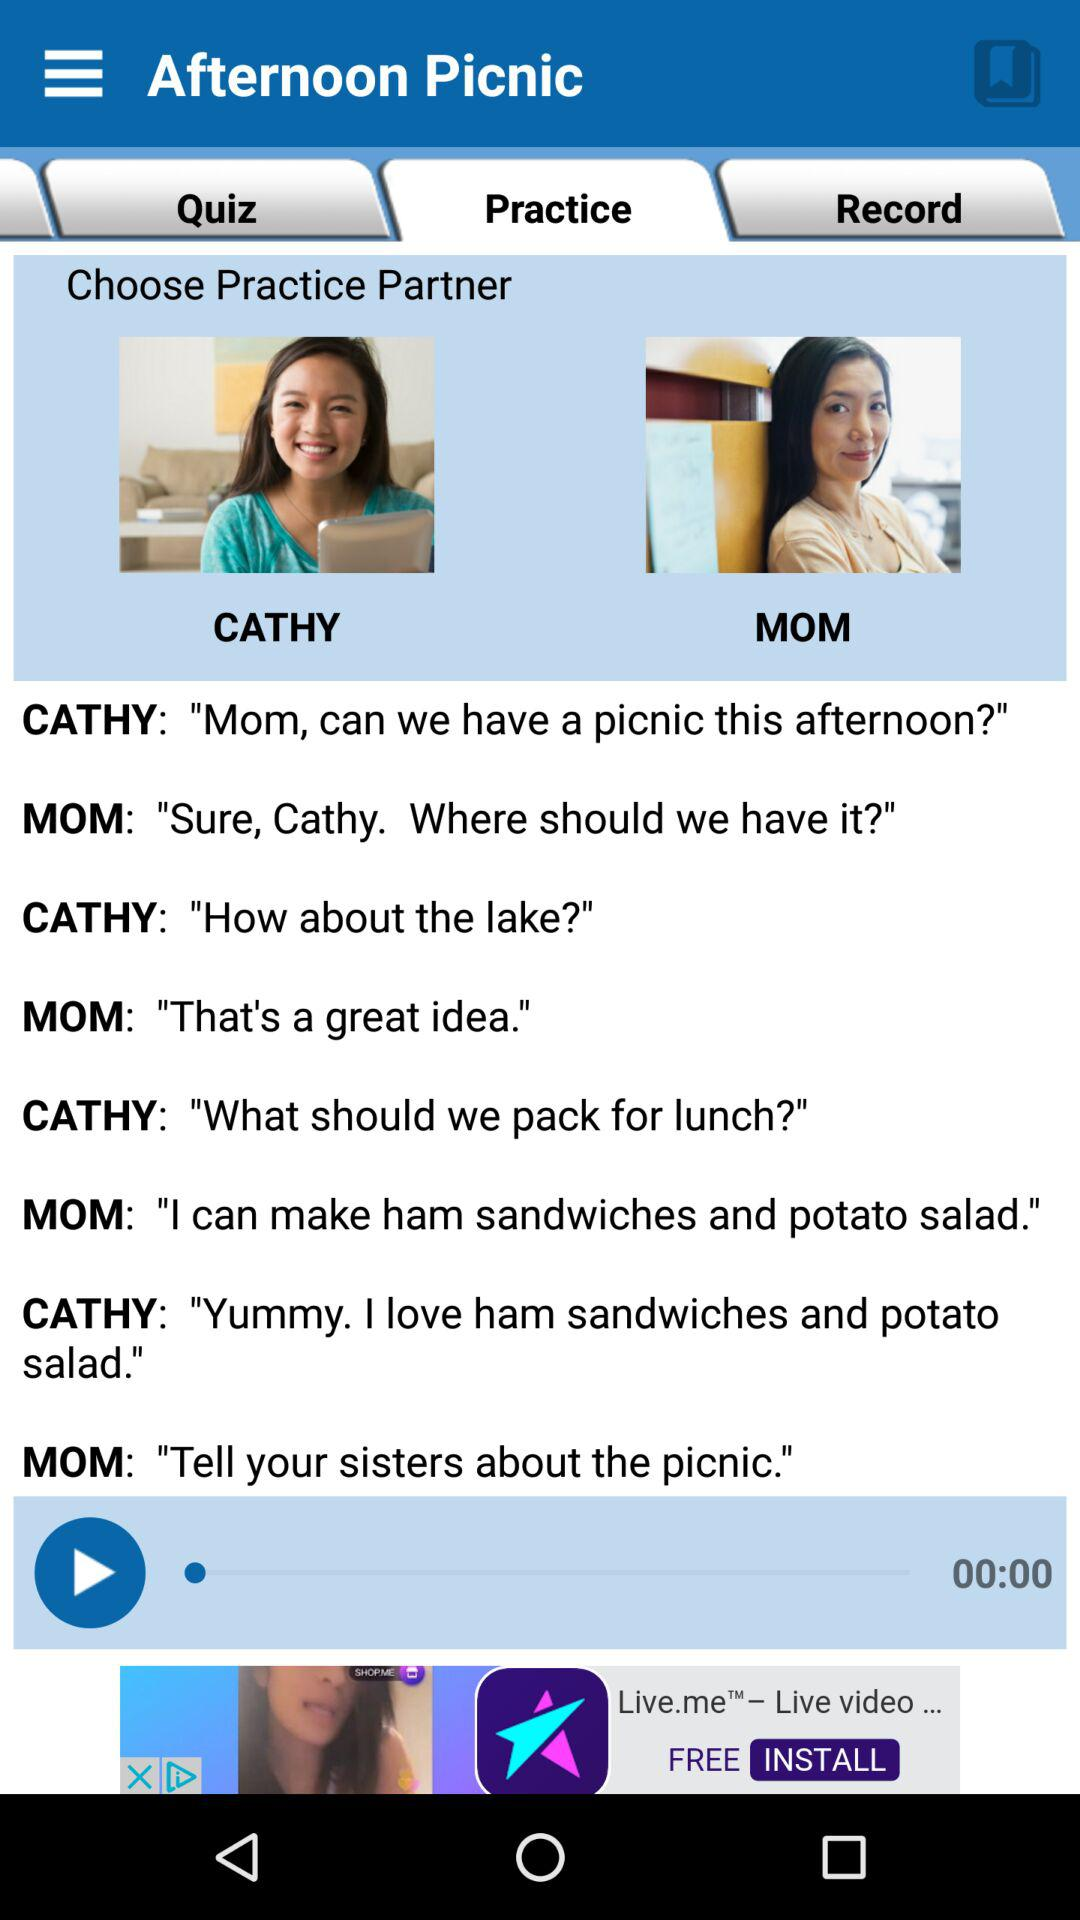What is the duration of the practice set?
When the provided information is insufficient, respond with <no answer>. <no answer> 